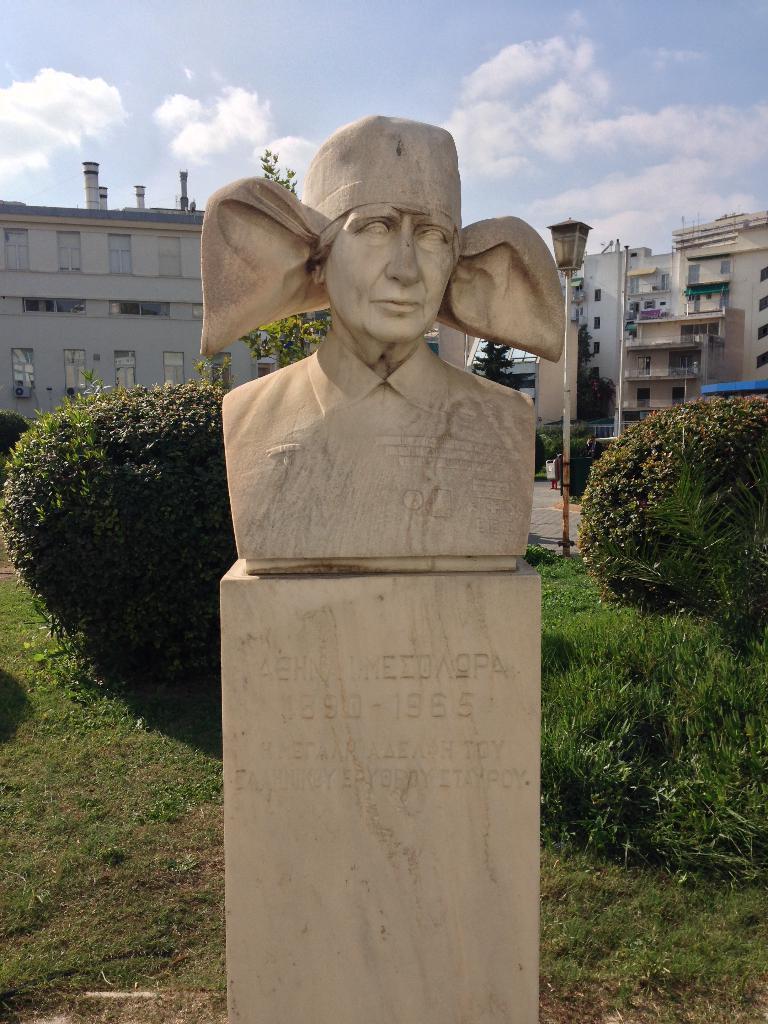Please provide a concise description of this image. In this picture we can see a statue, trees, buildings with windows and in the background we can see the sky with clouds. 